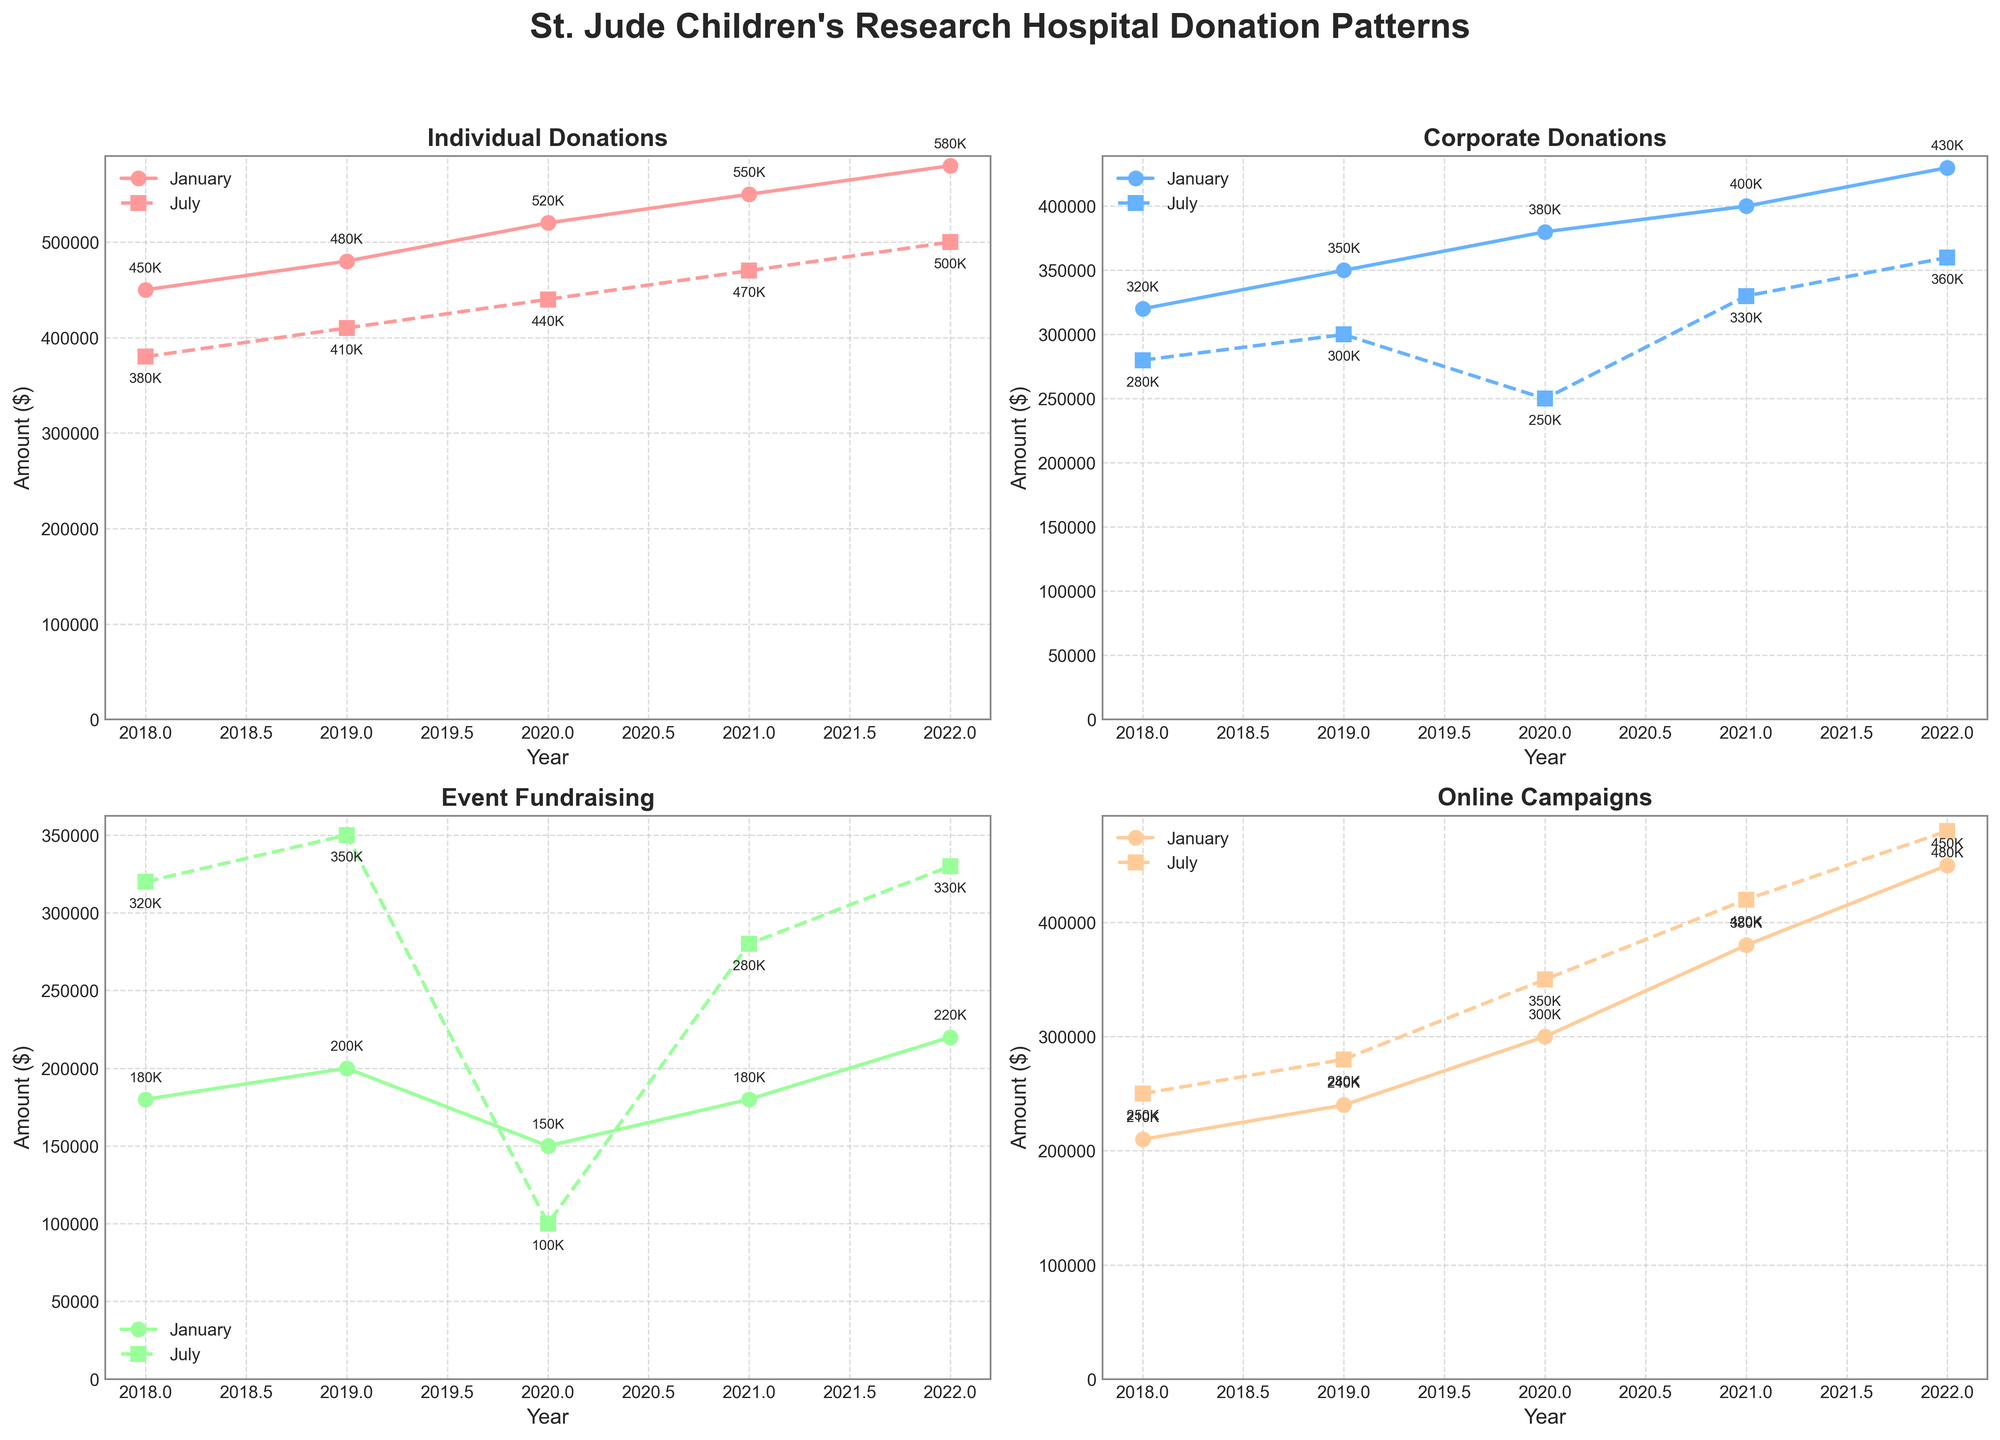What's the title of the figure? The title of the figure is usually displayed at the top of the plot. In this case, the figure contains the title "St. Jude Children's Research Hospital Donation Patterns".
Answer: St. Jude Children's Research Hospital Donation Patterns How are donations in July 2022 from Online Campaigns compared to January 2022? To answer this, we look at the subplot for "Online Campaigns" and observe the data points for January and July 2022. In July 2022, the donation from Online Campaigns is $480,000, whereas in January 2022, it is $450,000. Therefore, donations in July 2022 are higher.
Answer: Higher What trend do Individual Donations show over the years in January? To determine this, we examine the subplot for "Individual Donations" and observe the trend line for January data points. Over the years (2018 to 2022), donations in January consistently increase from $450,000 in 2018 to $580,000 in 2022.
Answer: Increasing trend Which donation category shows the least amount for July 2020? By checking the subplots for each category (i.e., Individual Donations, Corporate Donations, Event Fundraising, and Online Campaigns) for July 2020, Event Fundraising shows the least amount with donations at $100,000.
Answer: Event Fundraising What is the difference between Corporate Donations in January 2021 and January 2020? We locate the data points for Corporate Donations in January for both years on the appropriate subplot. The amounts are $400,000 in January 2021 and $380,000 in January 2020. The difference is $400,000 - $380,000 = $20,000.
Answer: $20,000 In which year did Event Fundraising in July surpass the January donations for the first time? Look at the subplot for "Event Fundraising" and compare January and July data points for each year. In 2021, July donations ($280,000) are higher than January donations ($180,000), which is the first occurrence of this trend.
Answer: 2021 Which month, January or July, generally shows higher Online Campaign donations across all years? By examining the Online Campaigns subplot, it is observed that July donations are consistently higher than January donations across all years from 2018 to 2022.
Answer: July What is the total amount donated through Corporate Donations in July across the 5 years? Sum the values of Corporate Donations in July from 2018 to 2022: $320,000 + $300,000 + $250,000 + $330,000 + $360,000 which equals $1,560,000.
Answer: $1,560,000 